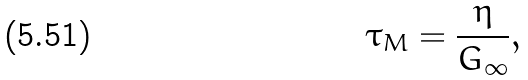<formula> <loc_0><loc_0><loc_500><loc_500>\tau _ { M } = \frac { \eta } { G _ { \infty } } ,</formula> 